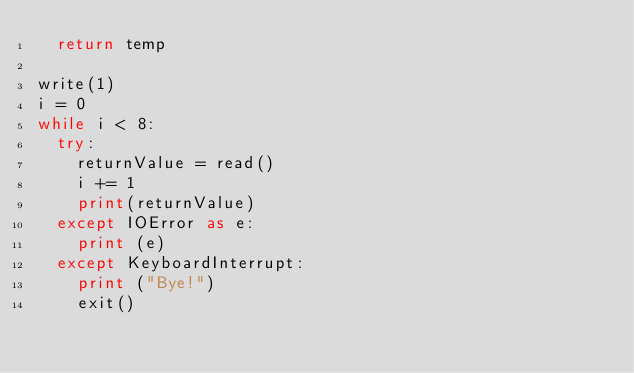<code> <loc_0><loc_0><loc_500><loc_500><_Python_>	return temp

write(1)
i = 0
while i < 8:
	try:
		returnValue = read()
		i += 1
		print(returnValue)
	except IOError as e:
		print (e)
	except KeyboardInterrupt:
		print ("Bye!")
		exit()
</code> 